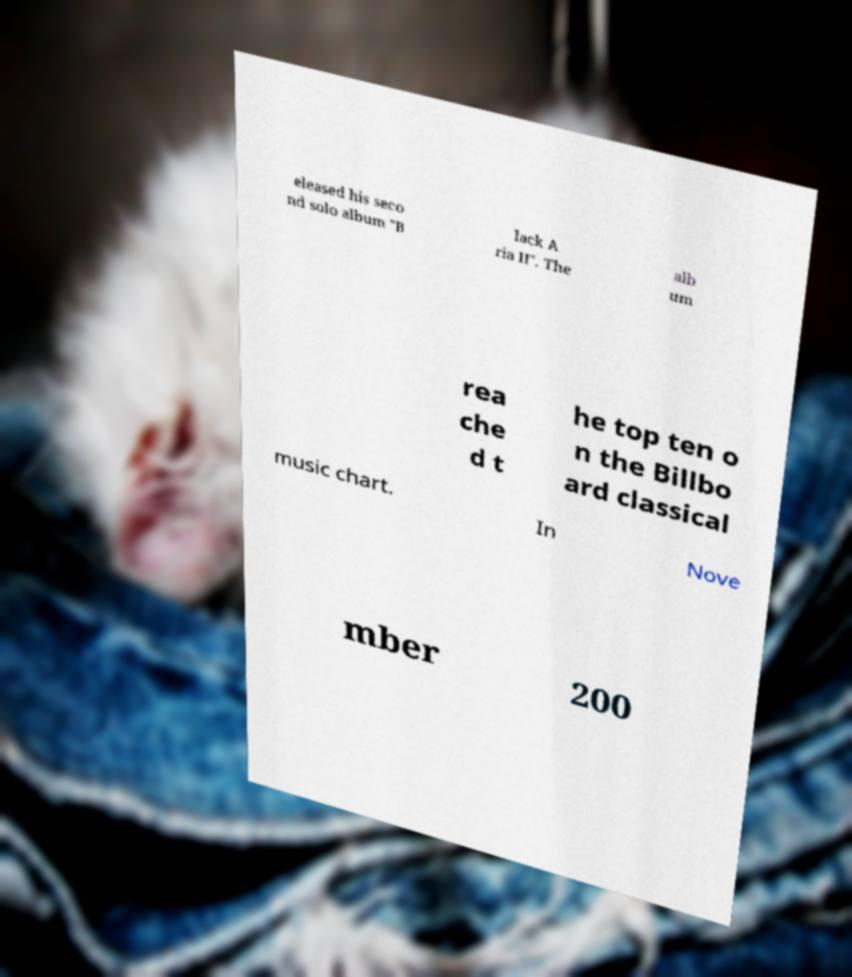Can you accurately transcribe the text from the provided image for me? eleased his seco nd solo album "B lack A ria II". The alb um rea che d t he top ten o n the Billbo ard classical music chart. In Nove mber 200 